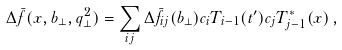Convert formula to latex. <formula><loc_0><loc_0><loc_500><loc_500>\Delta \bar { f } ( x , b _ { \perp } , q _ { \perp } ^ { 2 } ) = \sum _ { i j } \Delta \bar { f } _ { i j } ( b _ { \perp } ) c _ { i } T _ { i - 1 } ( t ^ { \prime } ) c _ { j } T ^ { * } _ { j - 1 } ( x ) \, ,</formula> 